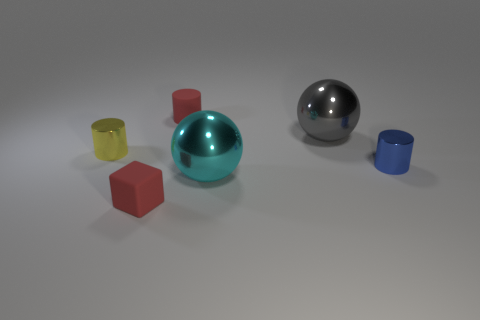Add 3 blue metal things. How many objects exist? 9 Subtract all spheres. How many objects are left? 4 Subtract 0 green spheres. How many objects are left? 6 Subtract all red things. Subtract all large things. How many objects are left? 2 Add 6 metal objects. How many metal objects are left? 10 Add 2 small yellow things. How many small yellow things exist? 3 